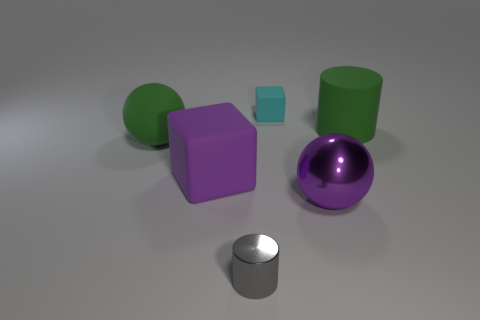Are there any red metal objects that have the same shape as the small gray thing?
Your response must be concise. No. Are there an equal number of rubber objects on the right side of the metal sphere and cyan rubber objects?
Provide a succinct answer. Yes. What material is the object left of the purple rubber thing on the left side of the small cyan matte cube?
Provide a short and direct response. Rubber. There is a purple metallic object; what shape is it?
Provide a succinct answer. Sphere. Are there an equal number of balls that are in front of the tiny gray shiny cylinder and small blocks that are to the left of the tiny cyan rubber block?
Your response must be concise. Yes. There is a sphere that is behind the big metallic object; does it have the same color as the cylinder that is behind the purple sphere?
Offer a terse response. Yes. Are there more large matte things to the right of the small cyan object than tiny brown things?
Provide a short and direct response. Yes. What shape is the big purple thing that is the same material as the gray cylinder?
Your response must be concise. Sphere. There is a ball left of the purple rubber cube; does it have the same size as the purple metallic object?
Your answer should be compact. Yes. What shape is the big matte object that is right of the large purple thing to the left of the purple metal thing?
Your answer should be very brief. Cylinder. 